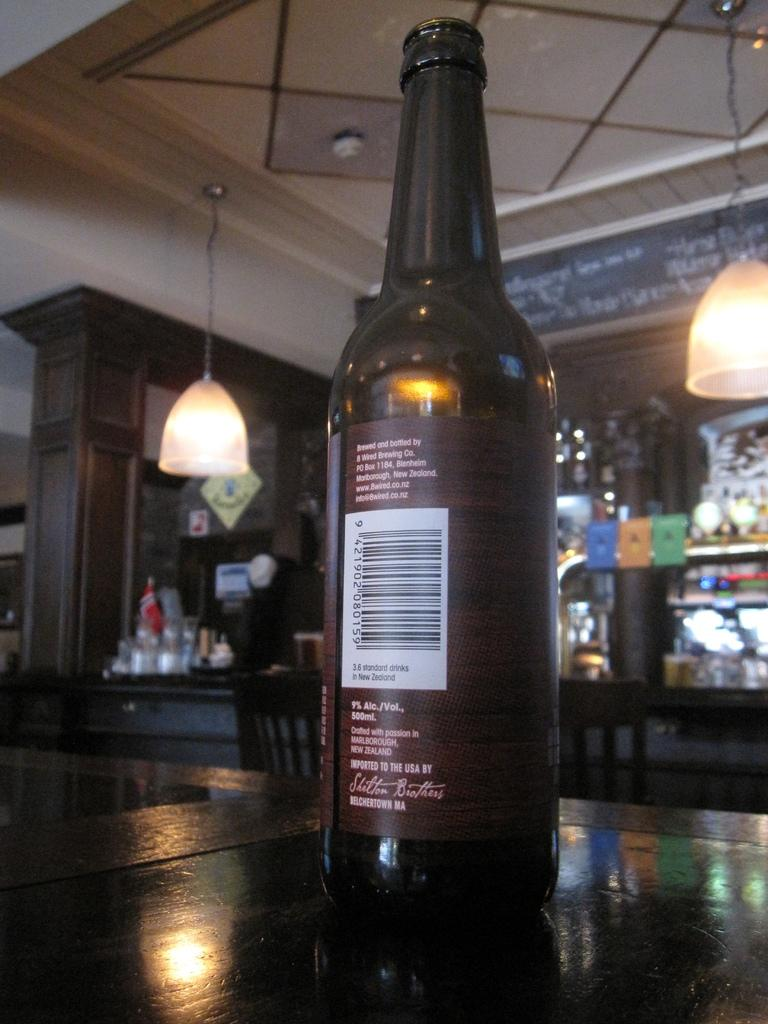What is on the table in the image? There is a wine bottle on the table. What type of setting is depicted in the background of the image? The background of the image appears to be a bar area. What can be seen hanging in the background? There are lights hanging in the background. Is there a pipe visible in the image? No, there is no pipe present in the image. Can you see a kitty playing with the wine bottle in the image? No, there is no kitty present in the image. 